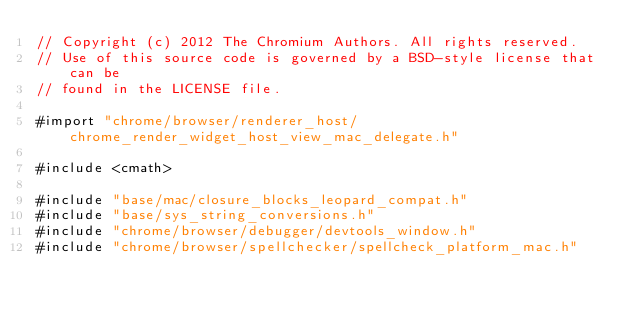<code> <loc_0><loc_0><loc_500><loc_500><_ObjectiveC_>// Copyright (c) 2012 The Chromium Authors. All rights reserved.
// Use of this source code is governed by a BSD-style license that can be
// found in the LICENSE file.

#import "chrome/browser/renderer_host/chrome_render_widget_host_view_mac_delegate.h"

#include <cmath>

#include "base/mac/closure_blocks_leopard_compat.h"
#include "base/sys_string_conversions.h"
#include "chrome/browser/debugger/devtools_window.h"
#include "chrome/browser/spellchecker/spellcheck_platform_mac.h"</code> 